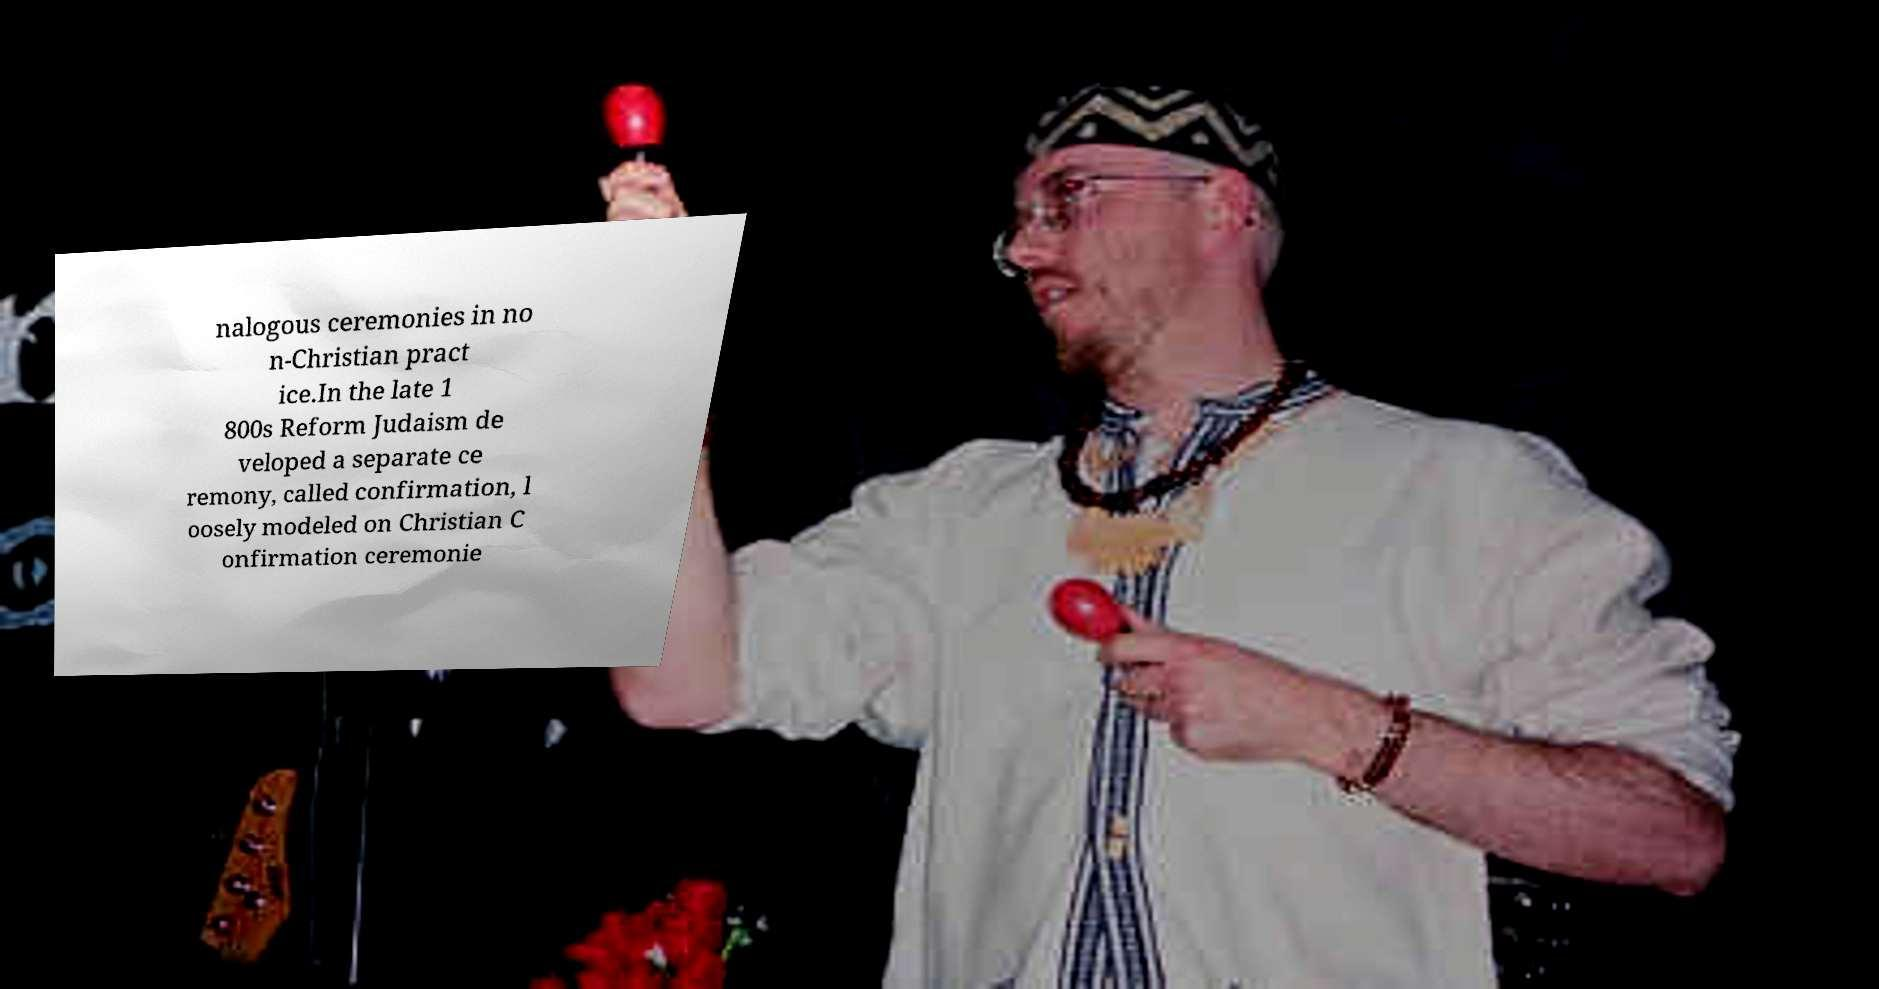Please read and relay the text visible in this image. What does it say? nalogous ceremonies in no n-Christian pract ice.In the late 1 800s Reform Judaism de veloped a separate ce remony, called confirmation, l oosely modeled on Christian C onfirmation ceremonie 